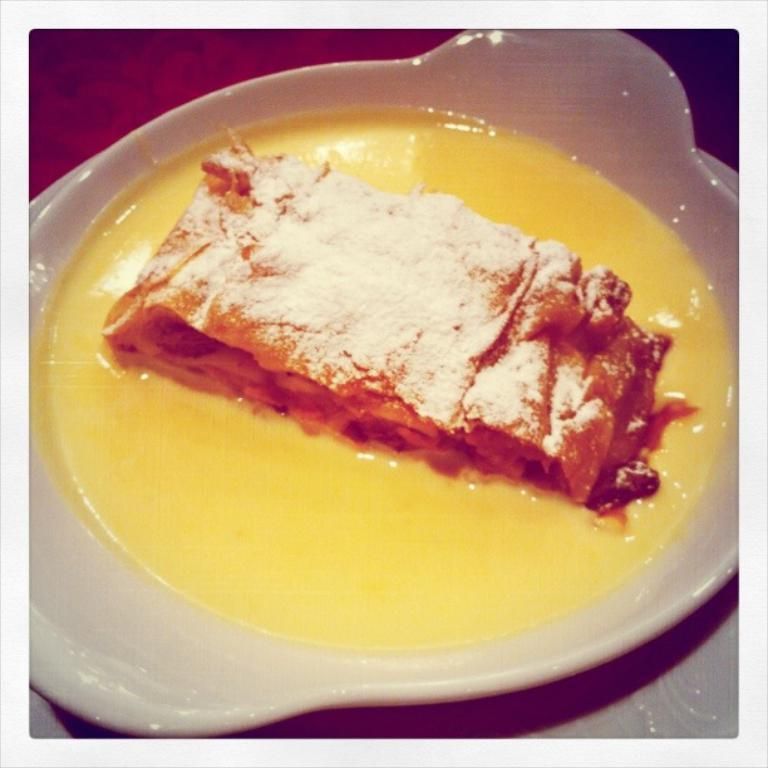What is the color of the plate in the image? The plate in the image is white. What colors can be seen in the food on the plate? The food on the plate has yellow and brown colors. What type of farm animals can be seen on the plate in the image? There are no farm animals present on the plate in the image. How many nations are represented by the food on the plate in the image? The food on the plate does not represent any nations; it is simply food with yellow and brown colors. 